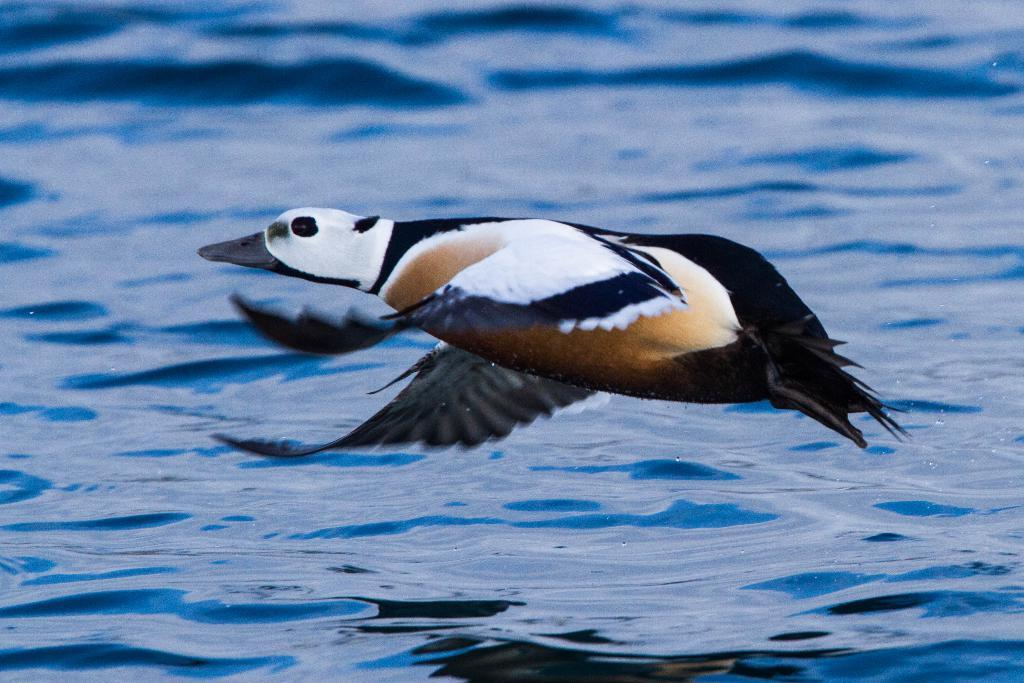What type of animal is in the image? There is a bird in the image. Can you describe the bird's coloring? The bird has black, brown, and white colors. What can be seen in the background of the image? Blue-colored water is visible in the image. What is the weight of the ladybug in the image? There is no ladybug present in the image, so it is not possible to determine its weight. 